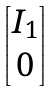Convert formula to latex. <formula><loc_0><loc_0><loc_500><loc_500>\begin{bmatrix} I _ { 1 } \\ 0 \\ \end{bmatrix}</formula> 